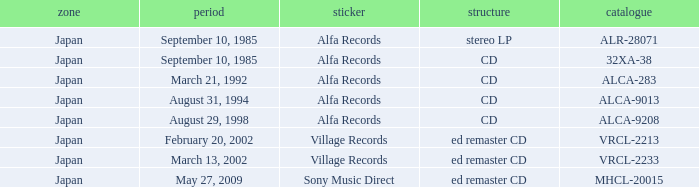Which Label was cataloged as alca-9013? Alfa Records. 